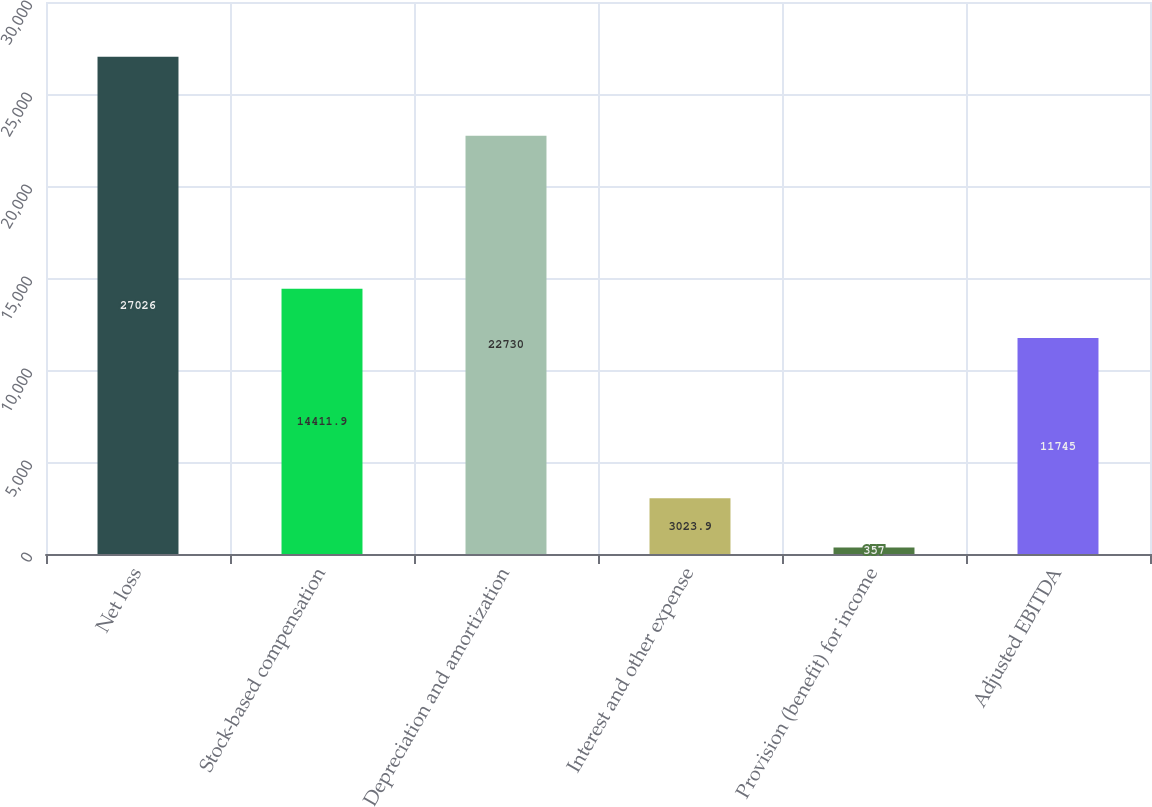Convert chart to OTSL. <chart><loc_0><loc_0><loc_500><loc_500><bar_chart><fcel>Net loss<fcel>Stock-based compensation<fcel>Depreciation and amortization<fcel>Interest and other expense<fcel>Provision (benefit) for income<fcel>Adjusted EBITDA<nl><fcel>27026<fcel>14411.9<fcel>22730<fcel>3023.9<fcel>357<fcel>11745<nl></chart> 